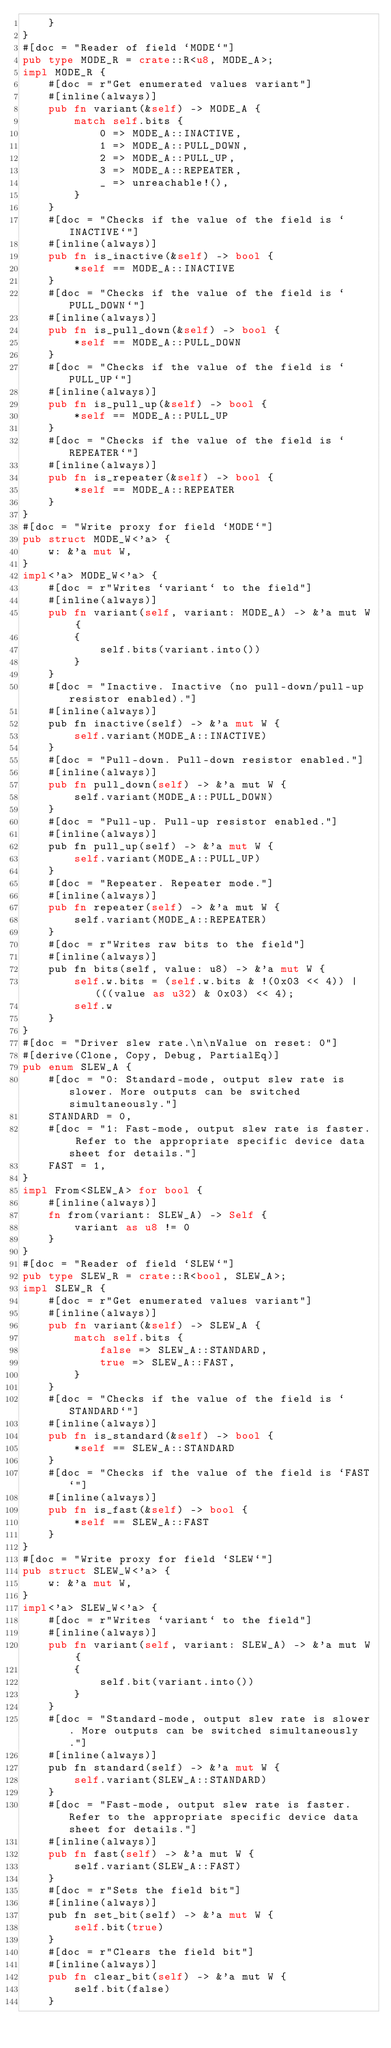<code> <loc_0><loc_0><loc_500><loc_500><_Rust_>    }
}
#[doc = "Reader of field `MODE`"]
pub type MODE_R = crate::R<u8, MODE_A>;
impl MODE_R {
    #[doc = r"Get enumerated values variant"]
    #[inline(always)]
    pub fn variant(&self) -> MODE_A {
        match self.bits {
            0 => MODE_A::INACTIVE,
            1 => MODE_A::PULL_DOWN,
            2 => MODE_A::PULL_UP,
            3 => MODE_A::REPEATER,
            _ => unreachable!(),
        }
    }
    #[doc = "Checks if the value of the field is `INACTIVE`"]
    #[inline(always)]
    pub fn is_inactive(&self) -> bool {
        *self == MODE_A::INACTIVE
    }
    #[doc = "Checks if the value of the field is `PULL_DOWN`"]
    #[inline(always)]
    pub fn is_pull_down(&self) -> bool {
        *self == MODE_A::PULL_DOWN
    }
    #[doc = "Checks if the value of the field is `PULL_UP`"]
    #[inline(always)]
    pub fn is_pull_up(&self) -> bool {
        *self == MODE_A::PULL_UP
    }
    #[doc = "Checks if the value of the field is `REPEATER`"]
    #[inline(always)]
    pub fn is_repeater(&self) -> bool {
        *self == MODE_A::REPEATER
    }
}
#[doc = "Write proxy for field `MODE`"]
pub struct MODE_W<'a> {
    w: &'a mut W,
}
impl<'a> MODE_W<'a> {
    #[doc = r"Writes `variant` to the field"]
    #[inline(always)]
    pub fn variant(self, variant: MODE_A) -> &'a mut W {
        {
            self.bits(variant.into())
        }
    }
    #[doc = "Inactive. Inactive (no pull-down/pull-up resistor enabled)."]
    #[inline(always)]
    pub fn inactive(self) -> &'a mut W {
        self.variant(MODE_A::INACTIVE)
    }
    #[doc = "Pull-down. Pull-down resistor enabled."]
    #[inline(always)]
    pub fn pull_down(self) -> &'a mut W {
        self.variant(MODE_A::PULL_DOWN)
    }
    #[doc = "Pull-up. Pull-up resistor enabled."]
    #[inline(always)]
    pub fn pull_up(self) -> &'a mut W {
        self.variant(MODE_A::PULL_UP)
    }
    #[doc = "Repeater. Repeater mode."]
    #[inline(always)]
    pub fn repeater(self) -> &'a mut W {
        self.variant(MODE_A::REPEATER)
    }
    #[doc = r"Writes raw bits to the field"]
    #[inline(always)]
    pub fn bits(self, value: u8) -> &'a mut W {
        self.w.bits = (self.w.bits & !(0x03 << 4)) | (((value as u32) & 0x03) << 4);
        self.w
    }
}
#[doc = "Driver slew rate.\n\nValue on reset: 0"]
#[derive(Clone, Copy, Debug, PartialEq)]
pub enum SLEW_A {
    #[doc = "0: Standard-mode, output slew rate is slower. More outputs can be switched simultaneously."]
    STANDARD = 0,
    #[doc = "1: Fast-mode, output slew rate is faster. Refer to the appropriate specific device data sheet for details."]
    FAST = 1,
}
impl From<SLEW_A> for bool {
    #[inline(always)]
    fn from(variant: SLEW_A) -> Self {
        variant as u8 != 0
    }
}
#[doc = "Reader of field `SLEW`"]
pub type SLEW_R = crate::R<bool, SLEW_A>;
impl SLEW_R {
    #[doc = r"Get enumerated values variant"]
    #[inline(always)]
    pub fn variant(&self) -> SLEW_A {
        match self.bits {
            false => SLEW_A::STANDARD,
            true => SLEW_A::FAST,
        }
    }
    #[doc = "Checks if the value of the field is `STANDARD`"]
    #[inline(always)]
    pub fn is_standard(&self) -> bool {
        *self == SLEW_A::STANDARD
    }
    #[doc = "Checks if the value of the field is `FAST`"]
    #[inline(always)]
    pub fn is_fast(&self) -> bool {
        *self == SLEW_A::FAST
    }
}
#[doc = "Write proxy for field `SLEW`"]
pub struct SLEW_W<'a> {
    w: &'a mut W,
}
impl<'a> SLEW_W<'a> {
    #[doc = r"Writes `variant` to the field"]
    #[inline(always)]
    pub fn variant(self, variant: SLEW_A) -> &'a mut W {
        {
            self.bit(variant.into())
        }
    }
    #[doc = "Standard-mode, output slew rate is slower. More outputs can be switched simultaneously."]
    #[inline(always)]
    pub fn standard(self) -> &'a mut W {
        self.variant(SLEW_A::STANDARD)
    }
    #[doc = "Fast-mode, output slew rate is faster. Refer to the appropriate specific device data sheet for details."]
    #[inline(always)]
    pub fn fast(self) -> &'a mut W {
        self.variant(SLEW_A::FAST)
    }
    #[doc = r"Sets the field bit"]
    #[inline(always)]
    pub fn set_bit(self) -> &'a mut W {
        self.bit(true)
    }
    #[doc = r"Clears the field bit"]
    #[inline(always)]
    pub fn clear_bit(self) -> &'a mut W {
        self.bit(false)
    }</code> 